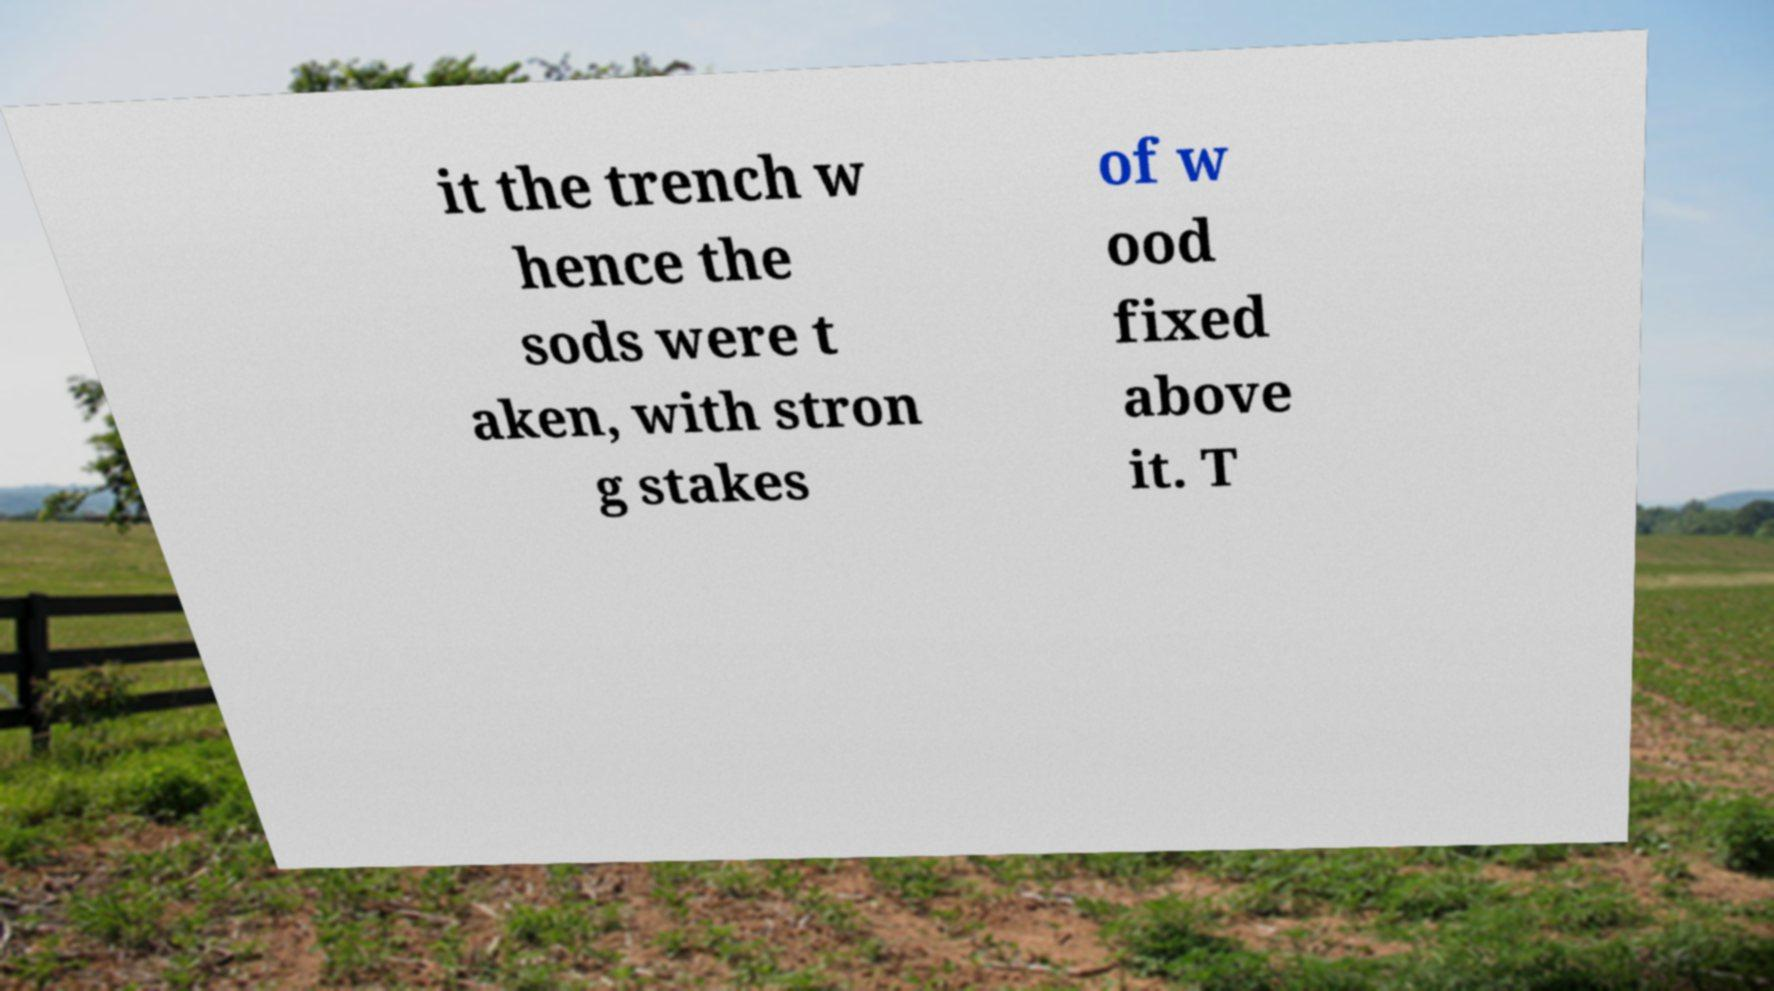Can you accurately transcribe the text from the provided image for me? it the trench w hence the sods were t aken, with stron g stakes of w ood fixed above it. T 